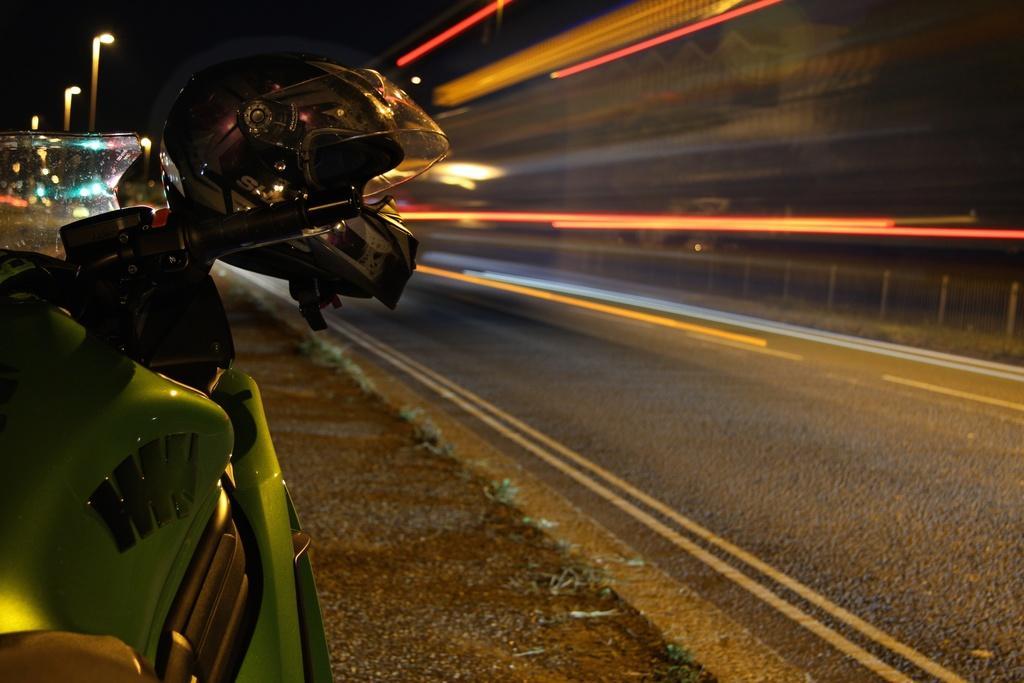Can you describe this image briefly? This is the picture of a road. On the left side of the image there is a motorbike and there is a helmet on the motor bike. At the back there are street lights. On the right side of the image there is a road. At the top there is sky. 